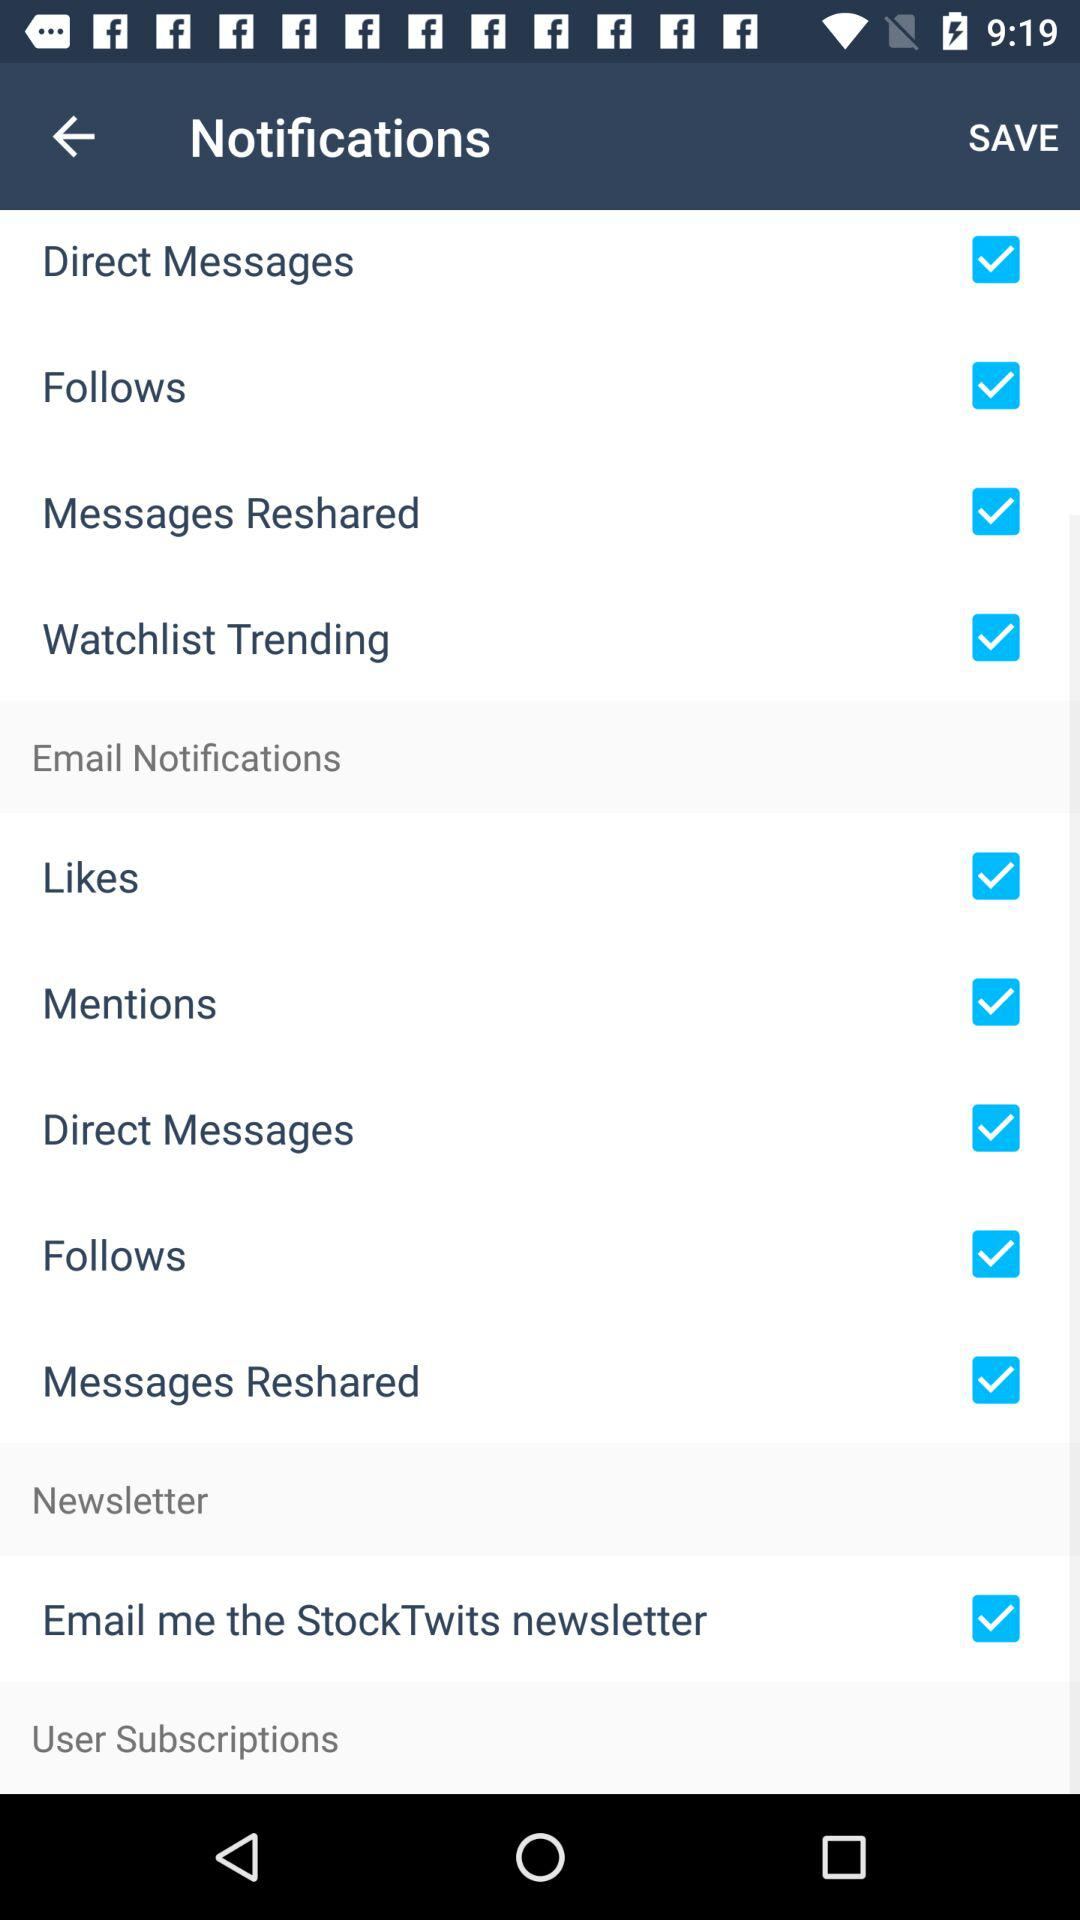What is the status of the "Mentions"? The status is on. 